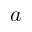<formula> <loc_0><loc_0><loc_500><loc_500>a</formula> 